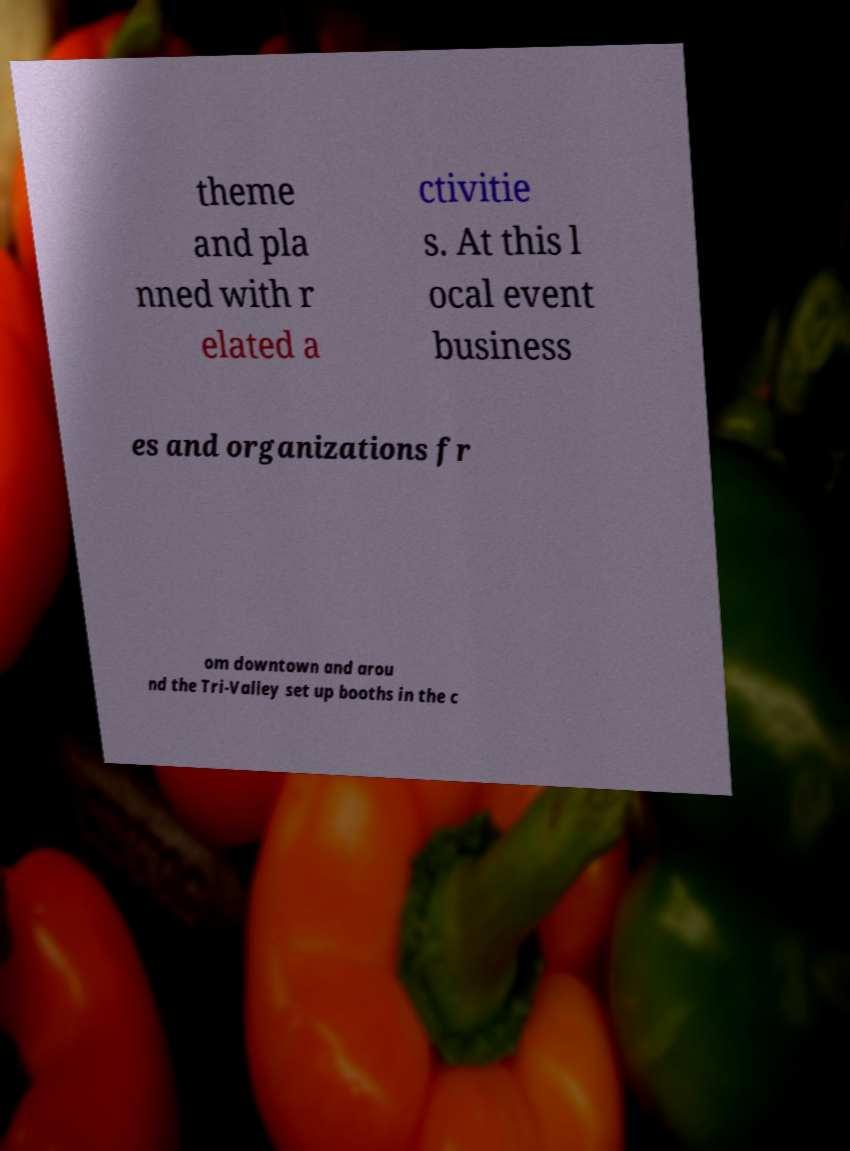Could you assist in decoding the text presented in this image and type it out clearly? theme and pla nned with r elated a ctivitie s. At this l ocal event business es and organizations fr om downtown and arou nd the Tri-Valley set up booths in the c 